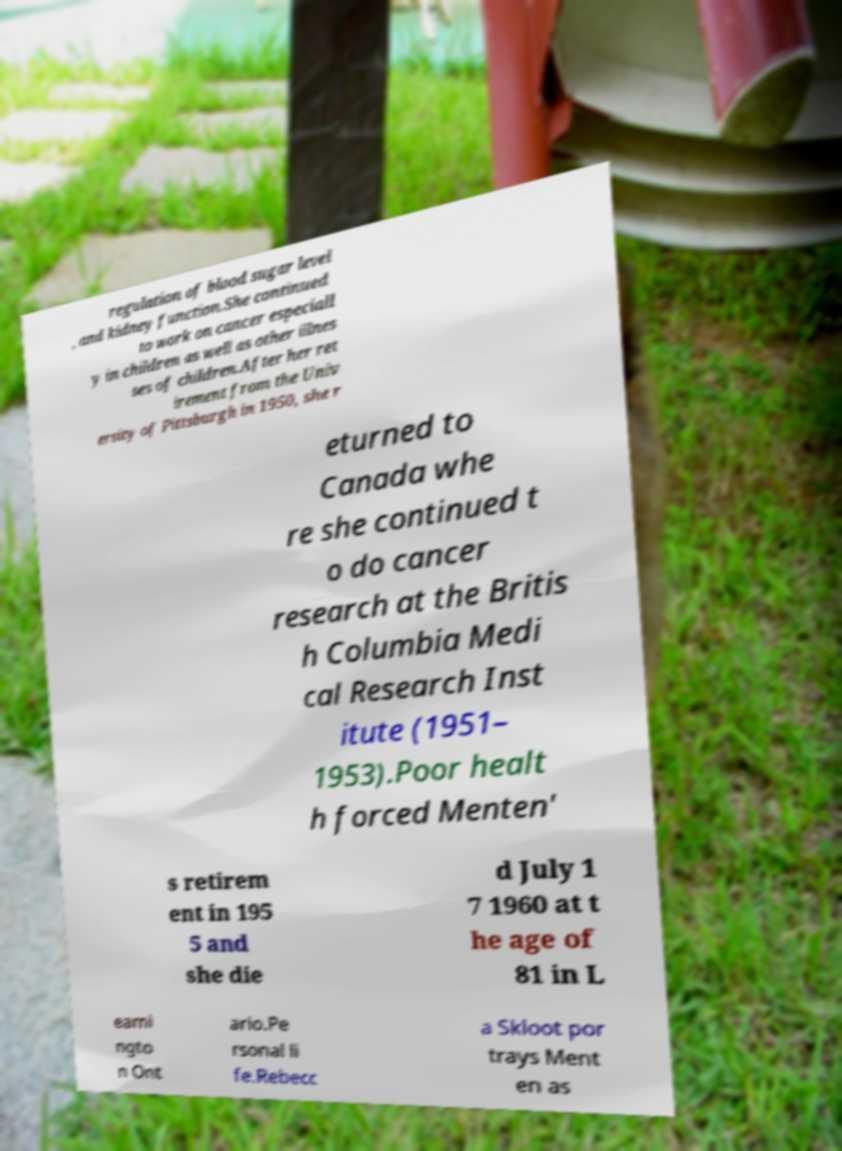There's text embedded in this image that I need extracted. Can you transcribe it verbatim? regulation of blood sugar level , and kidney function.She continued to work on cancer especiall y in children as well as other illnes ses of children.After her ret irement from the Univ ersity of Pittsburgh in 1950, she r eturned to Canada whe re she continued t o do cancer research at the Britis h Columbia Medi cal Research Inst itute (1951– 1953).Poor healt h forced Menten' s retirem ent in 195 5 and she die d July 1 7 1960 at t he age of 81 in L eami ngto n Ont ario.Pe rsonal li fe.Rebecc a Skloot por trays Ment en as 